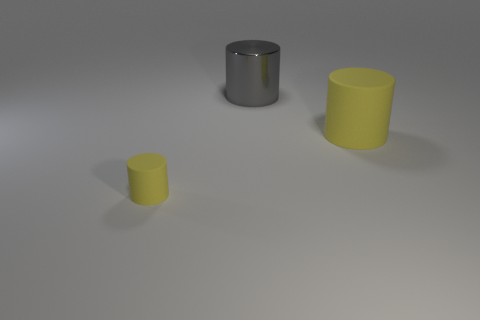Add 3 small cylinders. How many objects exist? 6 Add 3 gray metallic objects. How many gray metallic objects are left? 4 Add 1 brown rubber cylinders. How many brown rubber cylinders exist? 1 Subtract 0 green blocks. How many objects are left? 3 Subtract all large gray metal objects. Subtract all gray objects. How many objects are left? 1 